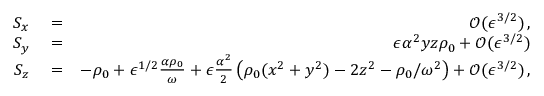<formula> <loc_0><loc_0><loc_500><loc_500>\begin{array} { r l r } { S _ { x } } & = } & { \mathcal { O } ( \epsilon ^ { 3 / 2 } ) \, , } \\ { S _ { y } } & = } & { \epsilon \alpha ^ { 2 } y z \rho _ { 0 } + \mathcal { O } ( \epsilon ^ { 3 / 2 } ) } \\ { S _ { z } } & = } & { - \rho _ { 0 } + \epsilon ^ { 1 / 2 } \frac { \alpha \rho _ { 0 } } { \omega } + \epsilon \frac { \alpha ^ { 2 } } { 2 } \left ( \rho _ { 0 } ( x ^ { 2 } + y ^ { 2 } ) - 2 z ^ { 2 } - \rho _ { 0 } / \omega ^ { 2 } \right ) + \mathcal { O } ( \epsilon ^ { 3 / 2 } ) \, , } \end{array}</formula> 